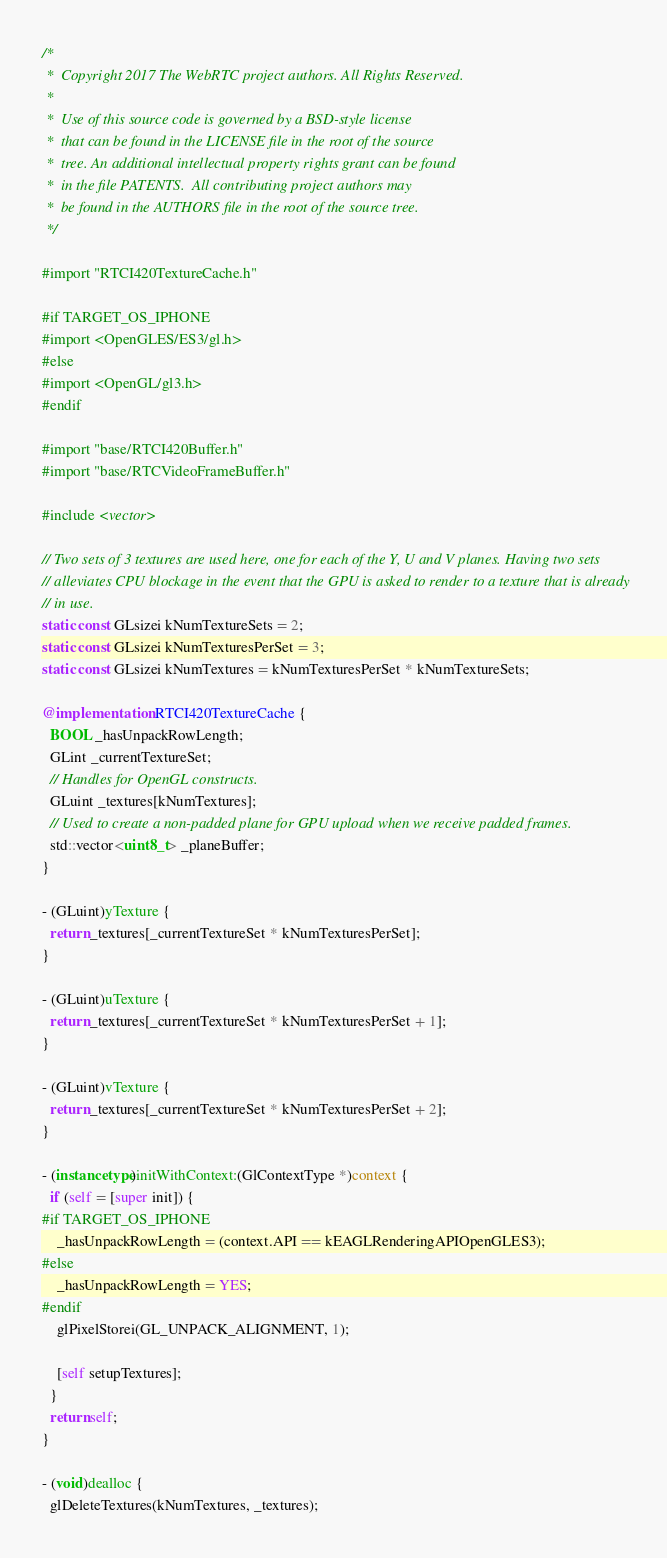Convert code to text. <code><loc_0><loc_0><loc_500><loc_500><_ObjectiveC_>/*
 *  Copyright 2017 The WebRTC project authors. All Rights Reserved.
 *
 *  Use of this source code is governed by a BSD-style license
 *  that can be found in the LICENSE file in the root of the source
 *  tree. An additional intellectual property rights grant can be found
 *  in the file PATENTS.  All contributing project authors may
 *  be found in the AUTHORS file in the root of the source tree.
 */

#import "RTCI420TextureCache.h"

#if TARGET_OS_IPHONE
#import <OpenGLES/ES3/gl.h>
#else
#import <OpenGL/gl3.h>
#endif

#import "base/RTCI420Buffer.h"
#import "base/RTCVideoFrameBuffer.h"

#include <vector>

// Two sets of 3 textures are used here, one for each of the Y, U and V planes. Having two sets
// alleviates CPU blockage in the event that the GPU is asked to render to a texture that is already
// in use.
static const GLsizei kNumTextureSets = 2;
static const GLsizei kNumTexturesPerSet = 3;
static const GLsizei kNumTextures = kNumTexturesPerSet * kNumTextureSets;

@implementation RTCI420TextureCache {
  BOOL _hasUnpackRowLength;
  GLint _currentTextureSet;
  // Handles for OpenGL constructs.
  GLuint _textures[kNumTextures];
  // Used to create a non-padded plane for GPU upload when we receive padded frames.
  std::vector<uint8_t> _planeBuffer;
}

- (GLuint)yTexture {
  return _textures[_currentTextureSet * kNumTexturesPerSet];
}

- (GLuint)uTexture {
  return _textures[_currentTextureSet * kNumTexturesPerSet + 1];
}

- (GLuint)vTexture {
  return _textures[_currentTextureSet * kNumTexturesPerSet + 2];
}

- (instancetype)initWithContext:(GlContextType *)context {
  if (self = [super init]) {
#if TARGET_OS_IPHONE
    _hasUnpackRowLength = (context.API == kEAGLRenderingAPIOpenGLES3);
#else
    _hasUnpackRowLength = YES;
#endif
    glPixelStorei(GL_UNPACK_ALIGNMENT, 1);

    [self setupTextures];
  }
  return self;
}

- (void)dealloc {
  glDeleteTextures(kNumTextures, _textures);</code> 